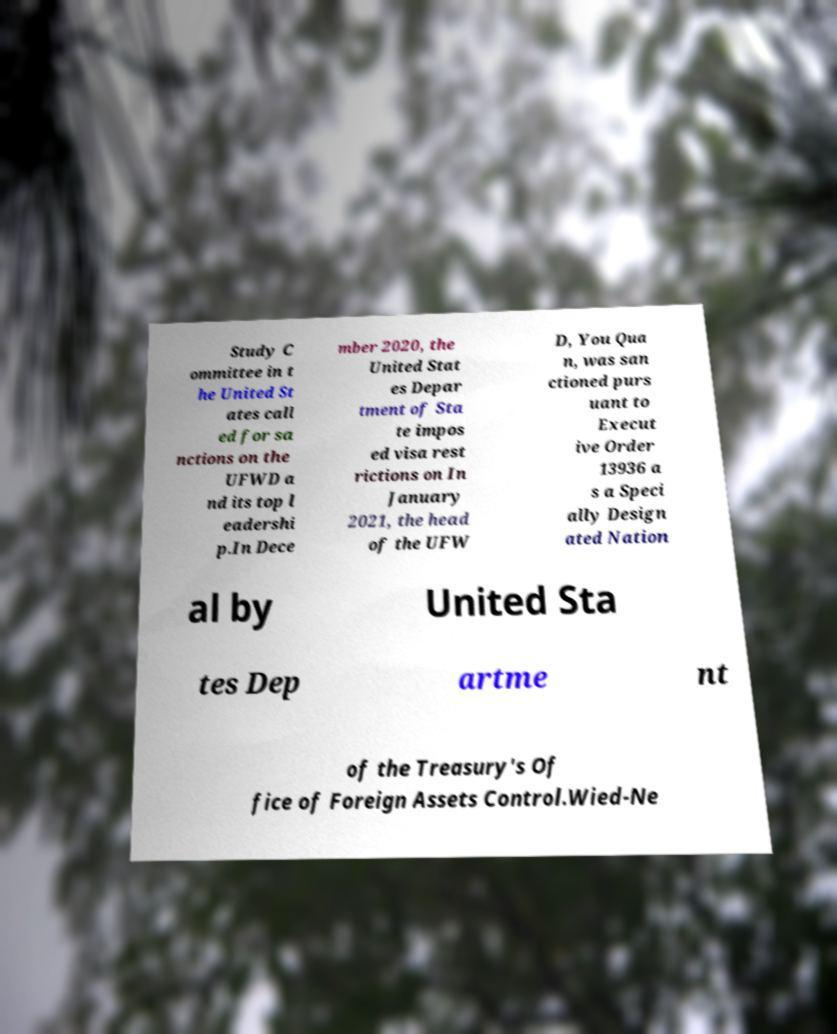Can you read and provide the text displayed in the image?This photo seems to have some interesting text. Can you extract and type it out for me? Study C ommittee in t he United St ates call ed for sa nctions on the UFWD a nd its top l eadershi p.In Dece mber 2020, the United Stat es Depar tment of Sta te impos ed visa rest rictions on In January 2021, the head of the UFW D, You Qua n, was san ctioned purs uant to Execut ive Order 13936 a s a Speci ally Design ated Nation al by United Sta tes Dep artme nt of the Treasury's Of fice of Foreign Assets Control.Wied-Ne 